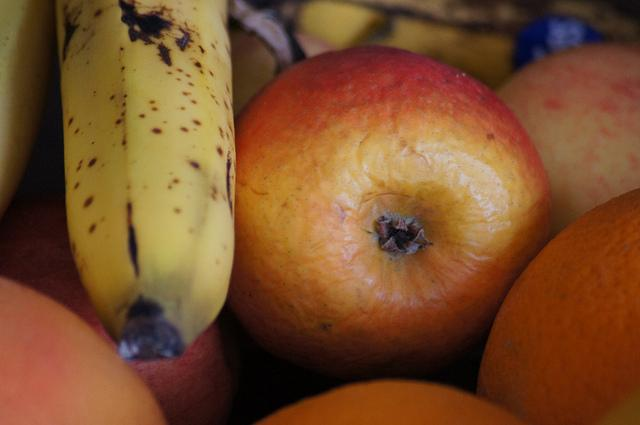What is the color of the fruit in the center of the pile? Please explain your reasoning. orange. The fruits location relative to each other is identifiable and the fruit in the center has a color that is recognizable. 